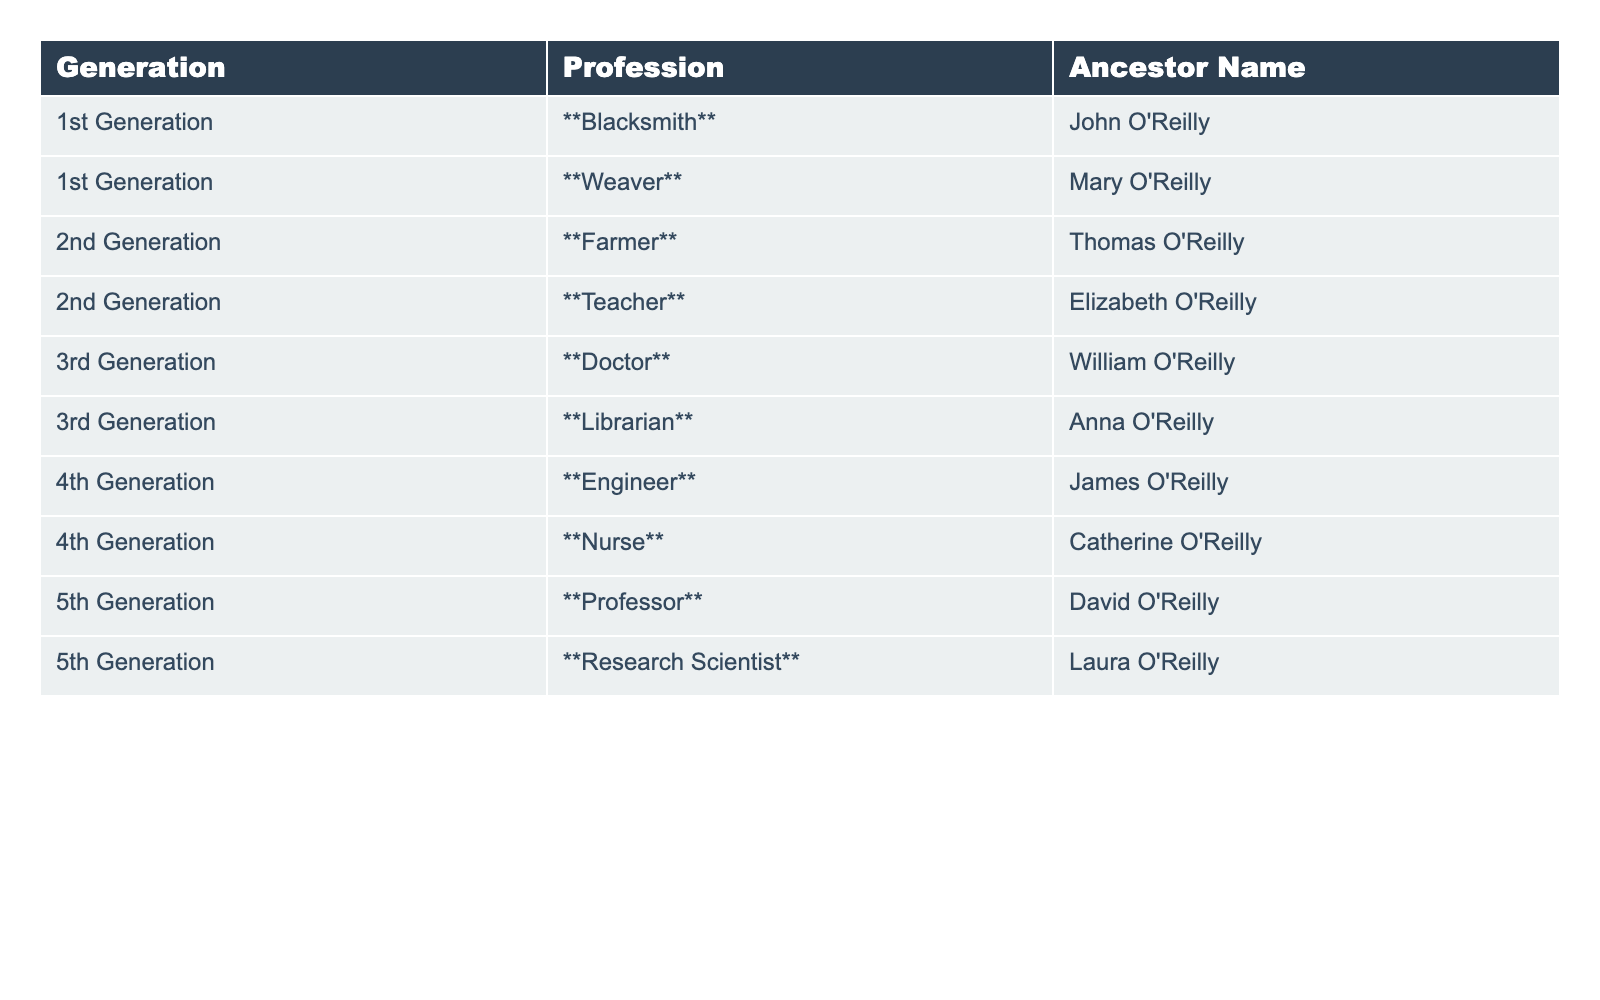What is the profession of the 3rd generation ancestor? The 3rd generation has two ancestors listed: William O'Reilly who was a Doctor and Anna O'Reilly who was a Librarian. The professions for the 3rd generation are Doctor and Librarian.
Answer: Doctor and Librarian Which ancestor was a Weaver? The table indicates that Mary O'Reilly was the ancestor who practiced the profession of Weaver.
Answer: Mary O'Reilly How many different professions are listed across all generations? The table lists a total of 10 different professions: Blacksmith, Weaver, Farmer, Teacher, Doctor, Librarian, Engineer, Nurse, Professor, and Research Scientist. Therefore, there are 10 unique professions.
Answer: 10 Which generation has the profession of Engineer? According to the table, the 4th generation has James O'Reilly listed as an Engineer, so the profession of Engineer belongs to the 4th generation.
Answer: 4th Generation Do any ancestors share the same profession? Examining the table reveals that each ancestor has a unique profession; no professions are repeated among the ancestors listed. So the answer is no.
Answer: No What is the total number of generations represented in the table? The table specifies 5 generations: 1st, 2nd, 3rd, 4th, and 5th. Counting these gives a total of 5 generations.
Answer: 5 Which profession appears last in the list based on generation? The last profession in the list according to the table is Research Scientist, which belongs to the 5th generation and is associated with Laura O'Reilly.
Answer: Research Scientist What is the difference between the highest and lowest generations listed? The highest generation listed is the 5th generation while the lowest is the 1st generation. The difference between them is 5 - 1 = 4 generations.
Answer: 4 Is there an ancestor in the 2nd generation who was a Teacher? The table indicates that Elizabeth O'Reilly is in the 2nd generation and was a Teacher, confirming that there is indeed an ancestor who fits this description.
Answer: Yes How many ancestors were in medical professions across the generations? The table lists William O'Reilly (Doctor) from the 3rd generation and Catherine O'Reilly (Nurse) from the 4th generation as the two ancestors in medical professions, totaling 2.
Answer: 2 